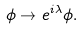Convert formula to latex. <formula><loc_0><loc_0><loc_500><loc_500>\phi \to e ^ { i \lambda } \phi .</formula> 